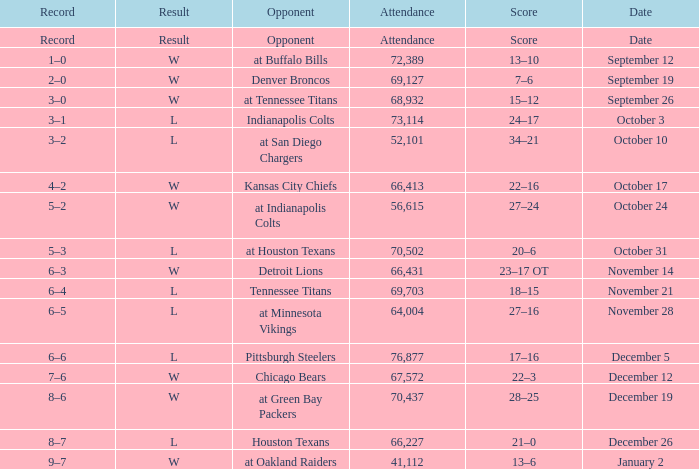What attendance has detroit lions as the opponent? 66431.0. Parse the table in full. {'header': ['Record', 'Result', 'Opponent', 'Attendance', 'Score', 'Date'], 'rows': [['Record', 'Result', 'Opponent', 'Attendance', 'Score', 'Date'], ['1–0', 'W', 'at Buffalo Bills', '72,389', '13–10', 'September 12'], ['2–0', 'W', 'Denver Broncos', '69,127', '7–6', 'September 19'], ['3–0', 'W', 'at Tennessee Titans', '68,932', '15–12', 'September 26'], ['3–1', 'L', 'Indianapolis Colts', '73,114', '24–17', 'October 3'], ['3–2', 'L', 'at San Diego Chargers', '52,101', '34–21', 'October 10'], ['4–2', 'W', 'Kansas City Chiefs', '66,413', '22–16', 'October 17'], ['5–2', 'W', 'at Indianapolis Colts', '56,615', '27–24', 'October 24'], ['5–3', 'L', 'at Houston Texans', '70,502', '20–6', 'October 31'], ['6–3', 'W', 'Detroit Lions', '66,431', '23–17 OT', 'November 14'], ['6–4', 'L', 'Tennessee Titans', '69,703', '18–15', 'November 21'], ['6–5', 'L', 'at Minnesota Vikings', '64,004', '27–16', 'November 28'], ['6–6', 'L', 'Pittsburgh Steelers', '76,877', '17–16', 'December 5'], ['7–6', 'W', 'Chicago Bears', '67,572', '22–3', 'December 12'], ['8–6', 'W', 'at Green Bay Packers', '70,437', '28–25', 'December 19'], ['8–7', 'L', 'Houston Texans', '66,227', '21–0', 'December 26'], ['9–7', 'W', 'at Oakland Raiders', '41,112', '13–6', 'January 2']]} 